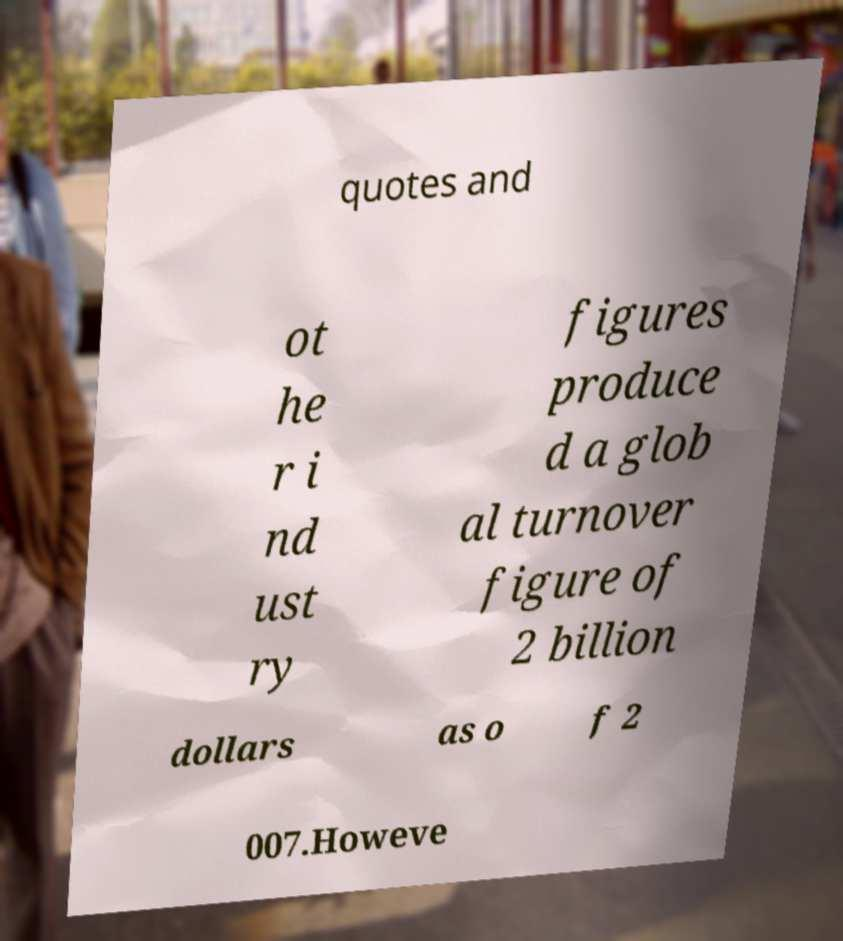Please read and relay the text visible in this image. What does it say? quotes and ot he r i nd ust ry figures produce d a glob al turnover figure of 2 billion dollars as o f 2 007.Howeve 